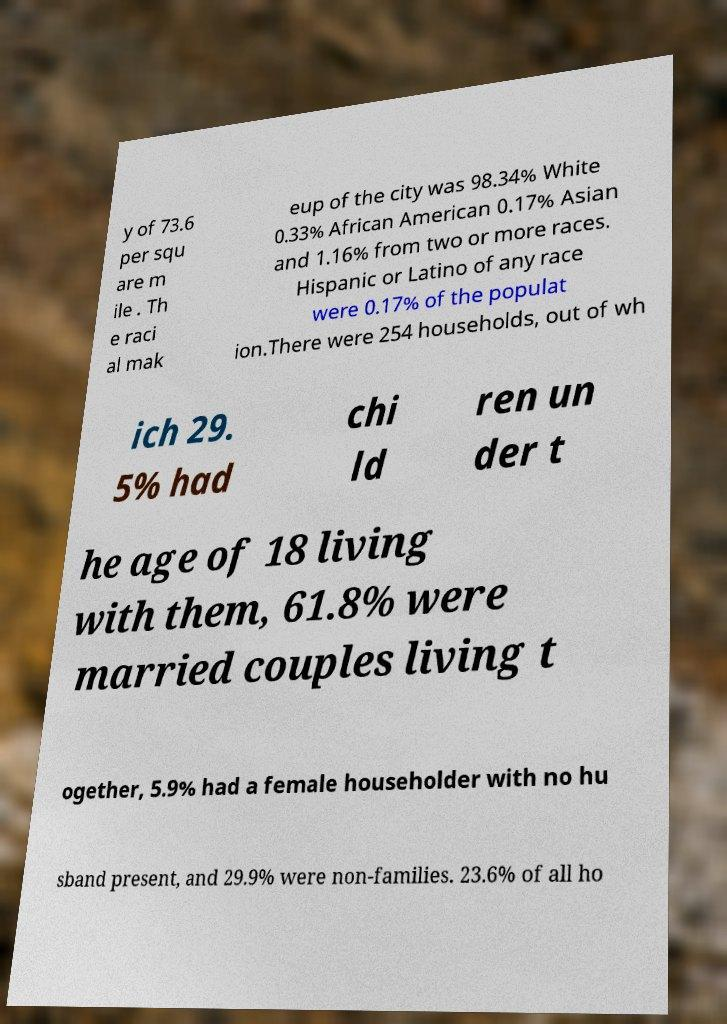For documentation purposes, I need the text within this image transcribed. Could you provide that? y of 73.6 per squ are m ile . Th e raci al mak eup of the city was 98.34% White 0.33% African American 0.17% Asian and 1.16% from two or more races. Hispanic or Latino of any race were 0.17% of the populat ion.There were 254 households, out of wh ich 29. 5% had chi ld ren un der t he age of 18 living with them, 61.8% were married couples living t ogether, 5.9% had a female householder with no hu sband present, and 29.9% were non-families. 23.6% of all ho 